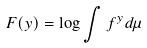Convert formula to latex. <formula><loc_0><loc_0><loc_500><loc_500>F ( y ) = \log \int f ^ { y } d \mu</formula> 